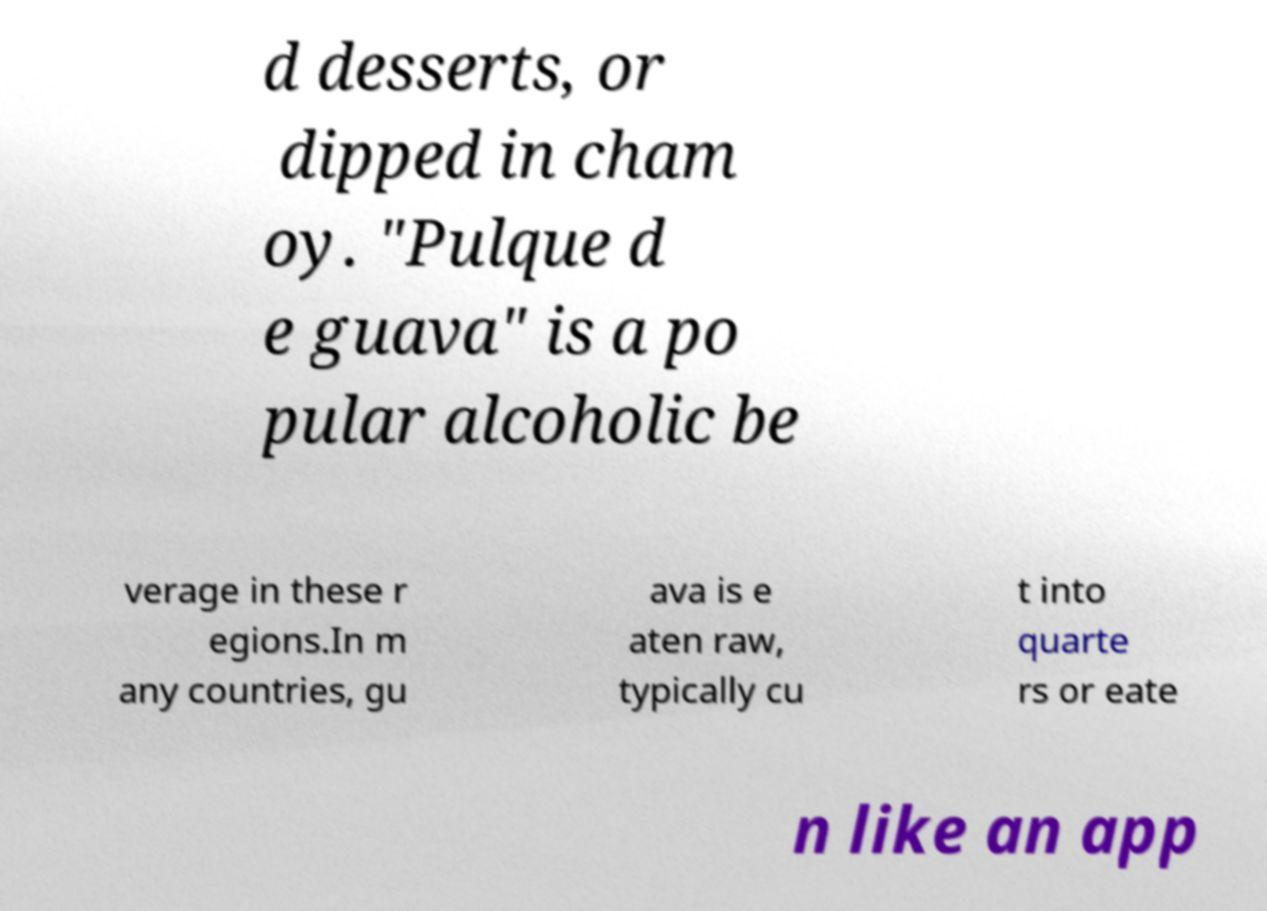Please read and relay the text visible in this image. What does it say? d desserts, or dipped in cham oy. "Pulque d e guava" is a po pular alcoholic be verage in these r egions.In m any countries, gu ava is e aten raw, typically cu t into quarte rs or eate n like an app 